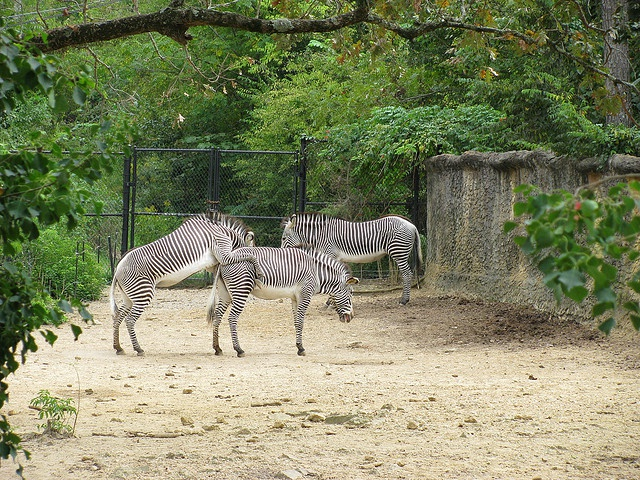Describe the objects in this image and their specific colors. I can see zebra in darkgreen, white, darkgray, gray, and black tones, zebra in darkgreen, white, darkgray, gray, and black tones, and zebra in darkgreen, black, gray, lightgray, and darkgray tones in this image. 